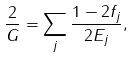<formula> <loc_0><loc_0><loc_500><loc_500>\frac { 2 } { G } = \sum _ { j } \frac { 1 - 2 f _ { j } } { 2 E _ { j } } ,</formula> 